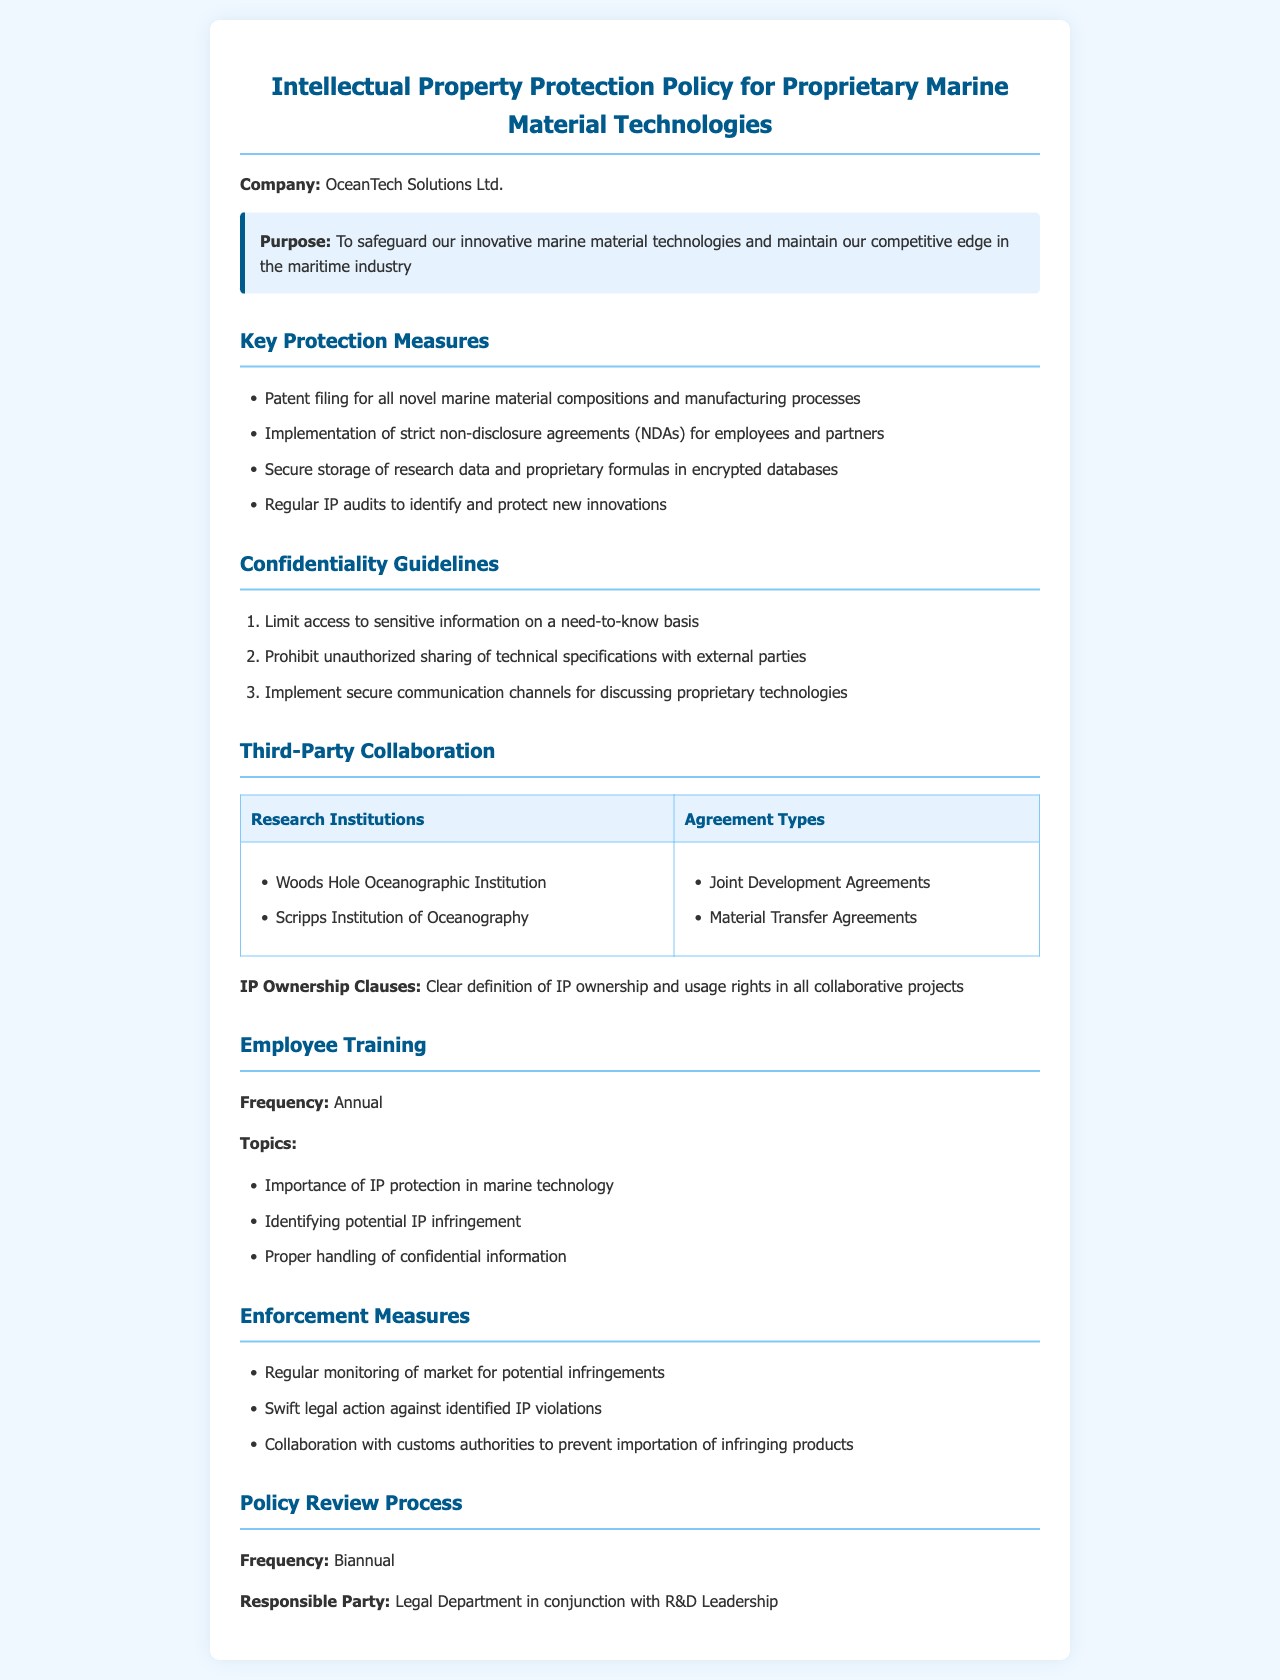what is the purpose of the policy? The purpose is to safeguard innovative marine material technologies and maintain a competitive edge in the maritime industry.
Answer: To safeguard our innovative marine material technologies and maintain our competitive edge in the maritime industry how often are IP audits conducted? The document states that regular IP audits are performed, but does not specify a frequency.
Answer: Regularly what institutions are mentioned for collaboration? The document lists Woods Hole Oceanographic Institution and Scripps Institution of Oceanography for collaboration.
Answer: Woods Hole Oceanographic Institution, Scripps Institution of Oceanography what are the document's confidentiality guidelines based on? The confidentiality guidelines are based on limiting access to sensitive information.
Answer: Need-to-know basis who is responsible for the policy review process? The document specifies that the Legal Department in conjunction with R&D Leadership is responsible for the review process.
Answer: Legal Department in conjunction with R&D Leadership how frequently is employee training conducted? The document indicates that employee training is conducted annually.
Answer: Annual what types of agreements are used for third-party collaboration? The document mentions Joint Development Agreements and Material Transfer Agreements for collaboration with third parties.
Answer: Joint Development Agreements, Material Transfer Agreements what is stated about enforcement measures? The document states that swift legal action will be taken against identified IP violations.
Answer: Swift legal action against identified IP violations what topics are covered in employee training? The training topics include the importance of IP protection in marine technology.
Answer: Importance of IP protection in marine technology 